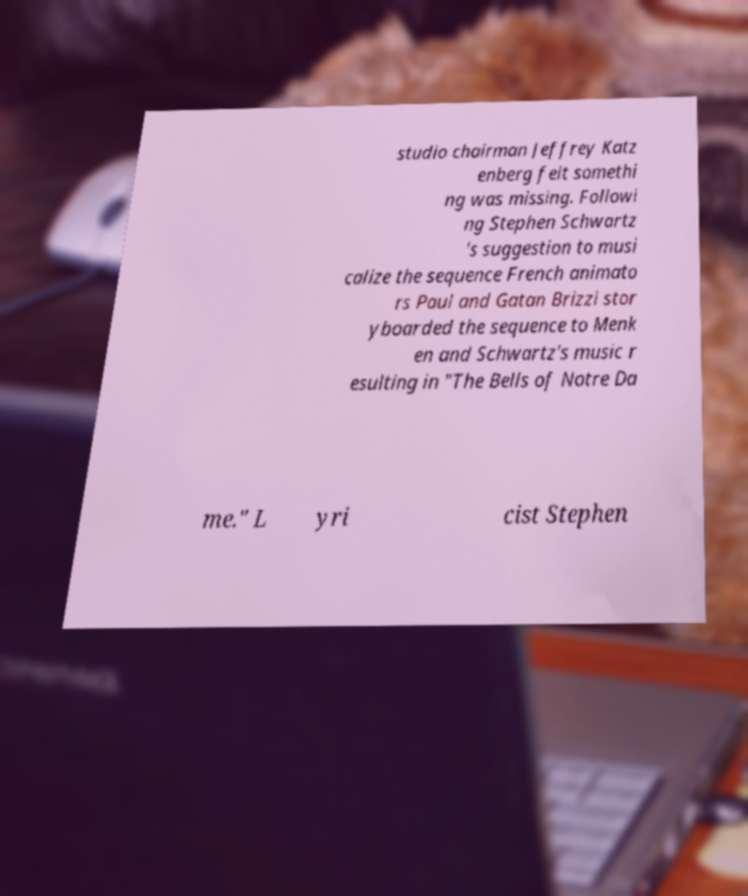I need the written content from this picture converted into text. Can you do that? studio chairman Jeffrey Katz enberg felt somethi ng was missing. Followi ng Stephen Schwartz 's suggestion to musi calize the sequence French animato rs Paul and Gatan Brizzi stor yboarded the sequence to Menk en and Schwartz's music r esulting in "The Bells of Notre Da me." L yri cist Stephen 